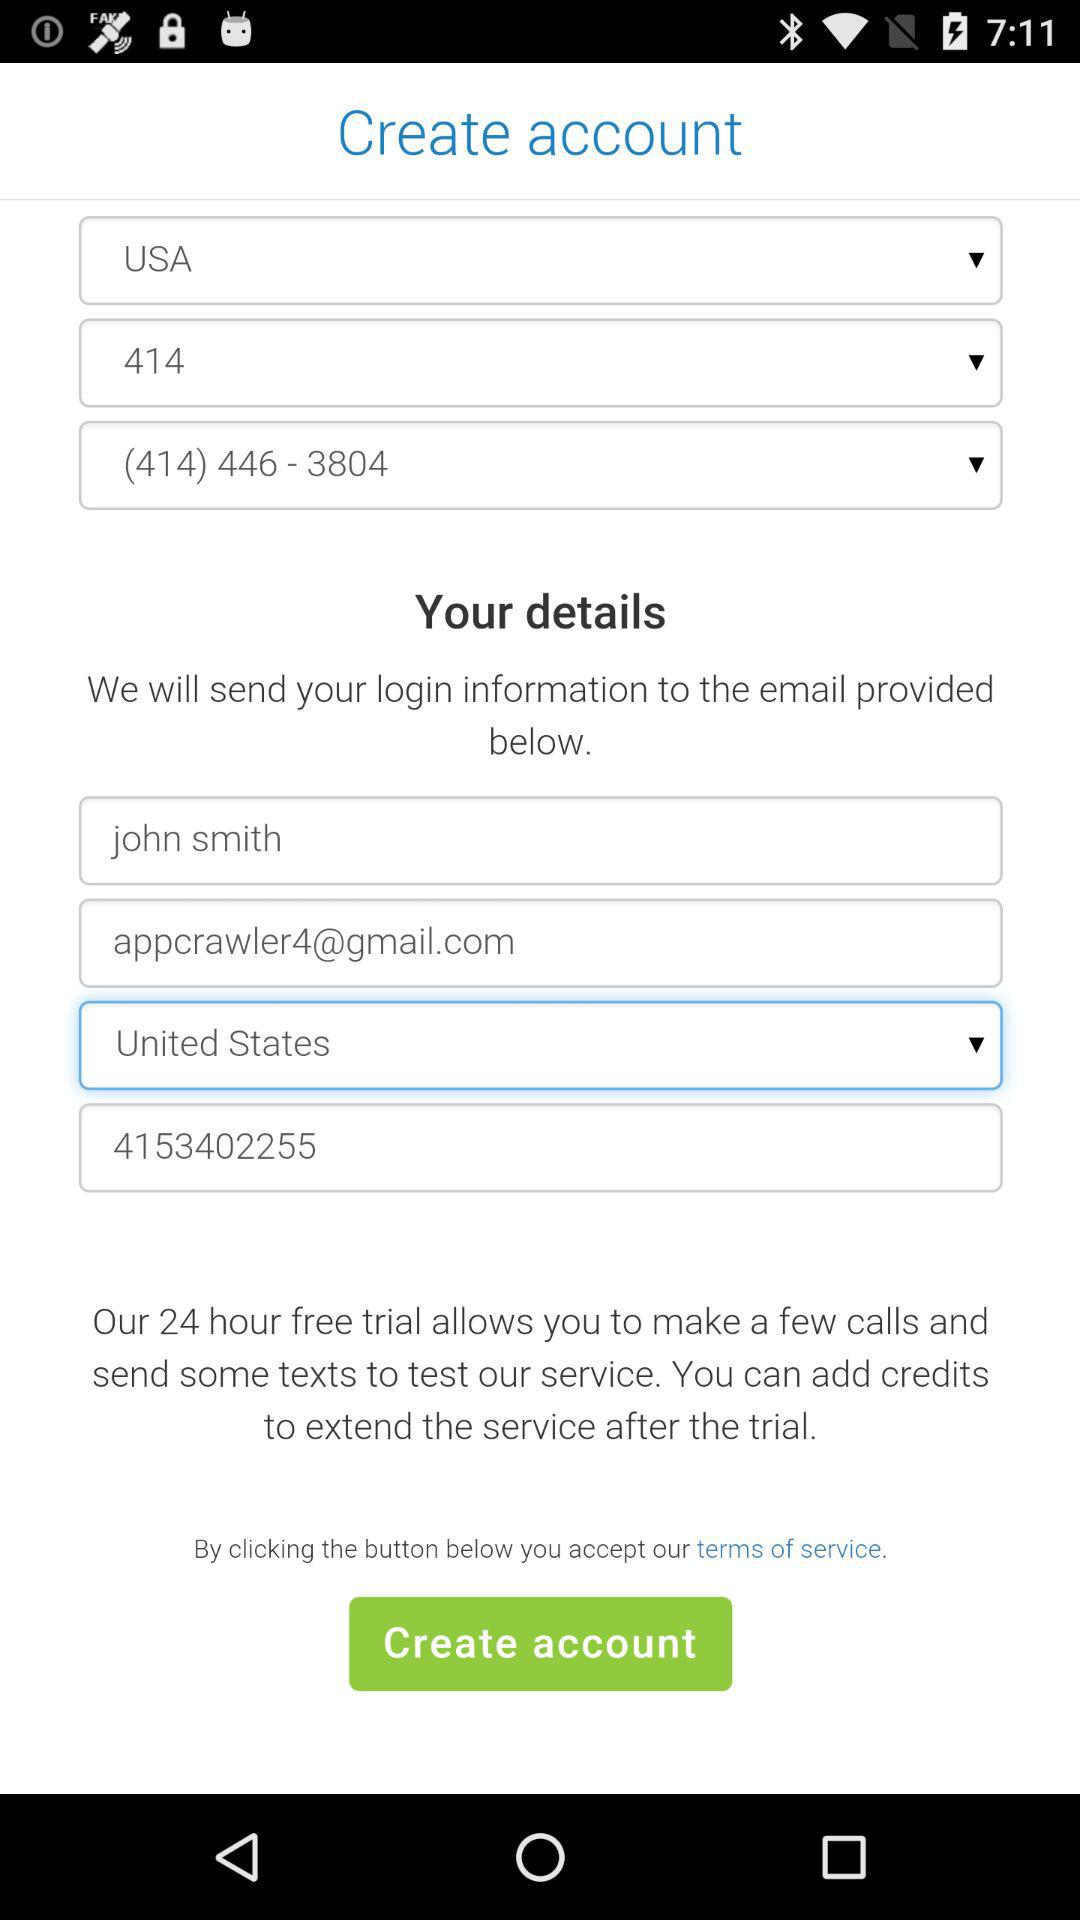Has the user agreed to the terms of service?
When the provided information is insufficient, respond with <no answer>. <no answer> 